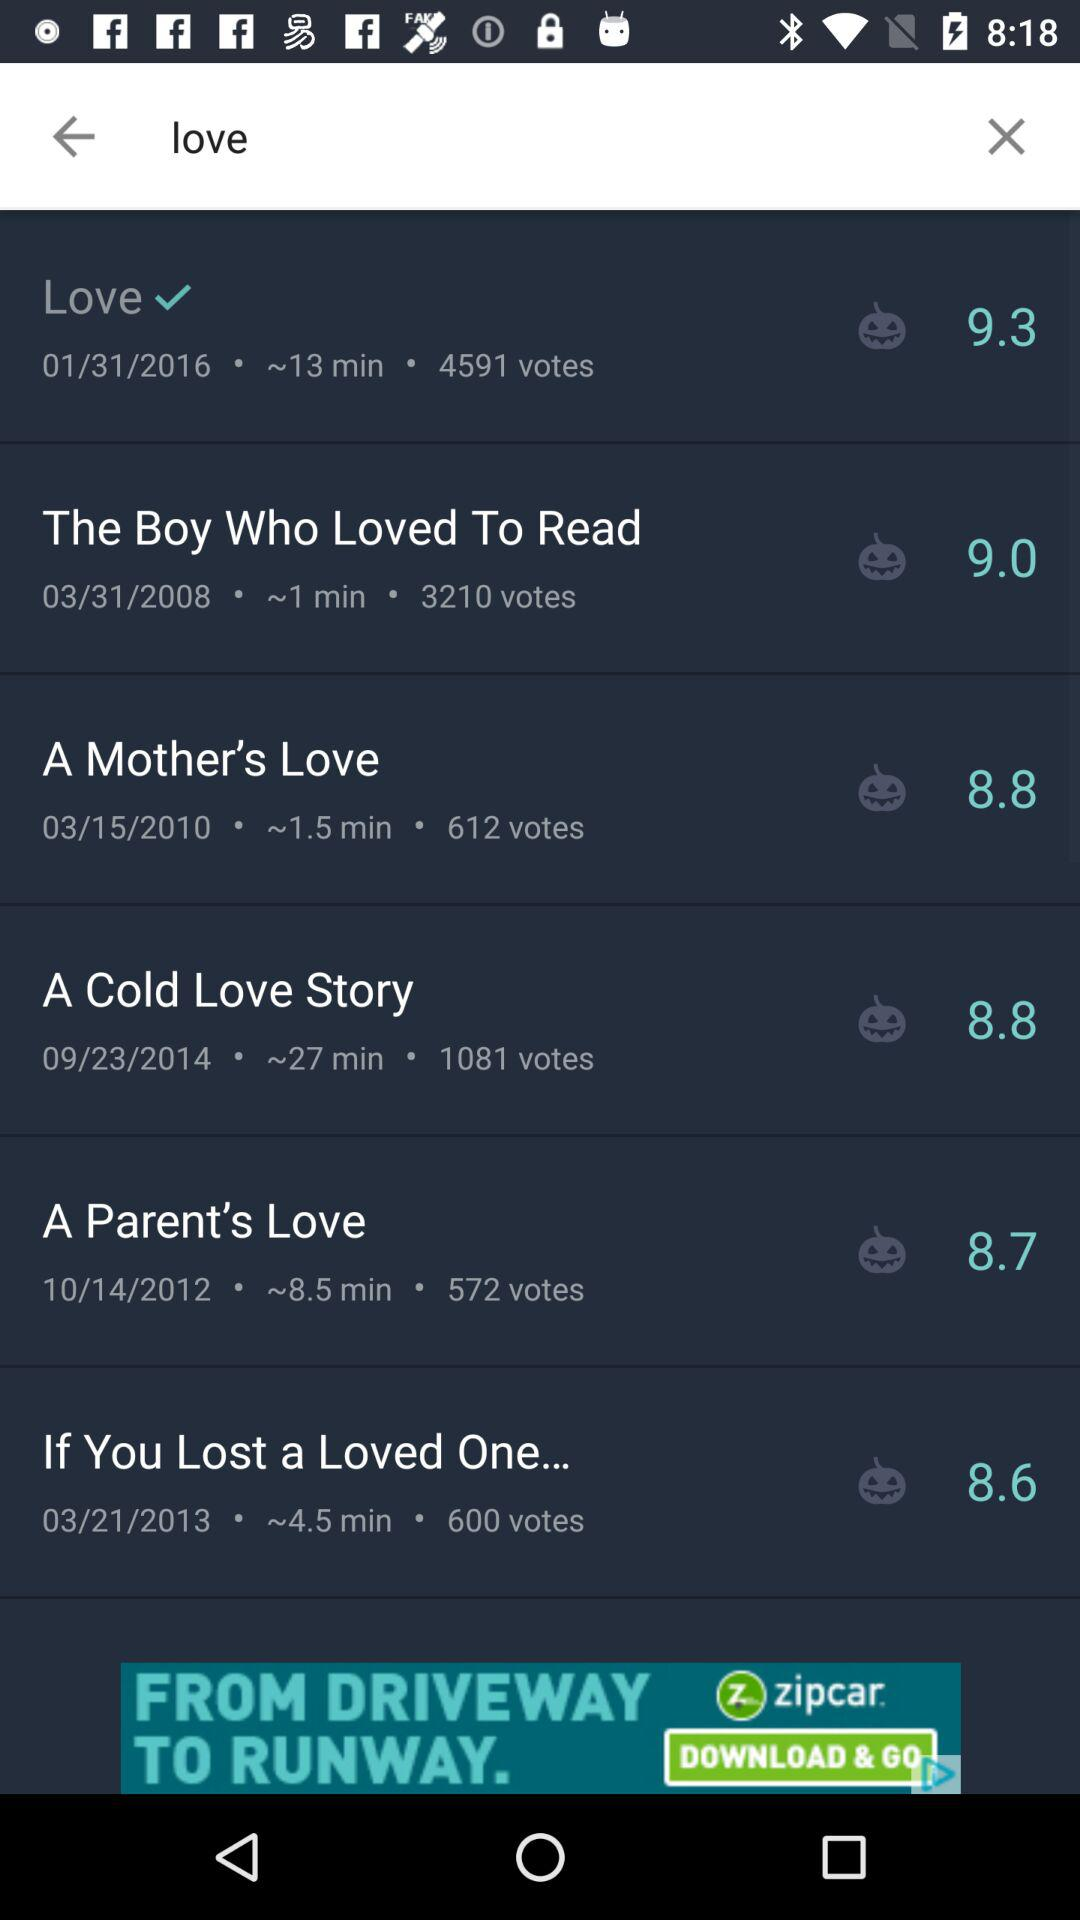How many votes did "A Mother's Love" get? "A Mother's Love" got 3210 votes. 